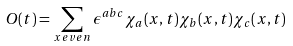<formula> <loc_0><loc_0><loc_500><loc_500>O ( t ) = \sum _ { x \, e v e n } \epsilon ^ { a b c } \chi _ { a } ( x , t ) \chi _ { b } ( x , t ) \chi _ { c } ( x , t )</formula> 